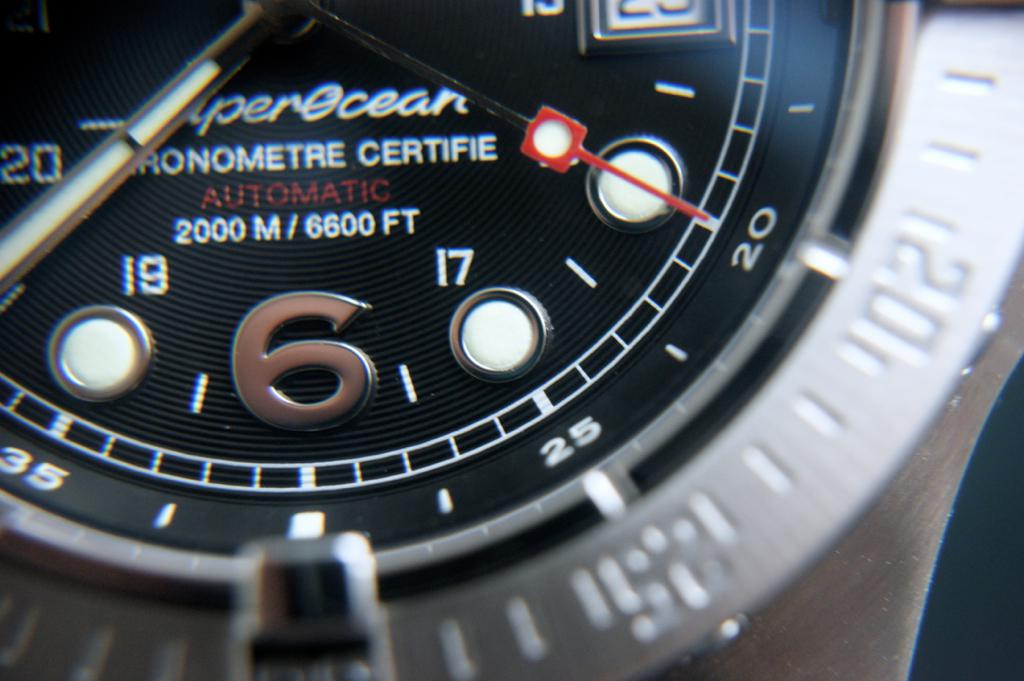What details can you tell about the watch's construction and design? The watch features a robust design with a stainless steel case, a unidirectional rotating bezel, and a thick sapphire crystal to endure deep diving pressures. The face of the watch has a clean and functional layout with luminous markers and a date window at the 3 o'clock position. 